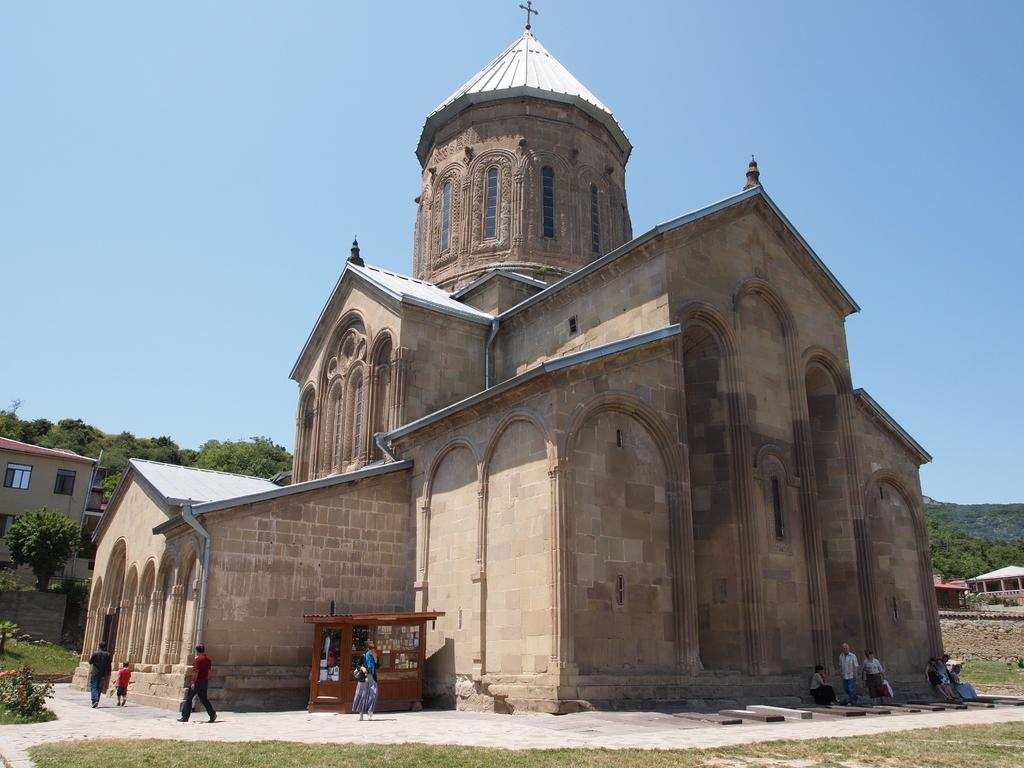What type of structure is present in the image? There is a building in the image. What other natural elements can be seen in the image? There are trees and grass in the image. Are there any living beings in the image? Yes, there are people in the image. What is visible at the top of the image? The sky is visible at the top of the image. Can you see the toes of the people in the image? There is no information about the toes of the people in the image, as the focus is on the presence of the building, trees, grass, and people. 